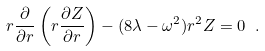<formula> <loc_0><loc_0><loc_500><loc_500>r \frac { \partial } { \partial r } \left ( r \frac { \partial Z } { \partial r } \right ) - ( 8 \lambda - \omega ^ { 2 } ) r ^ { 2 } Z = 0 \ .</formula> 